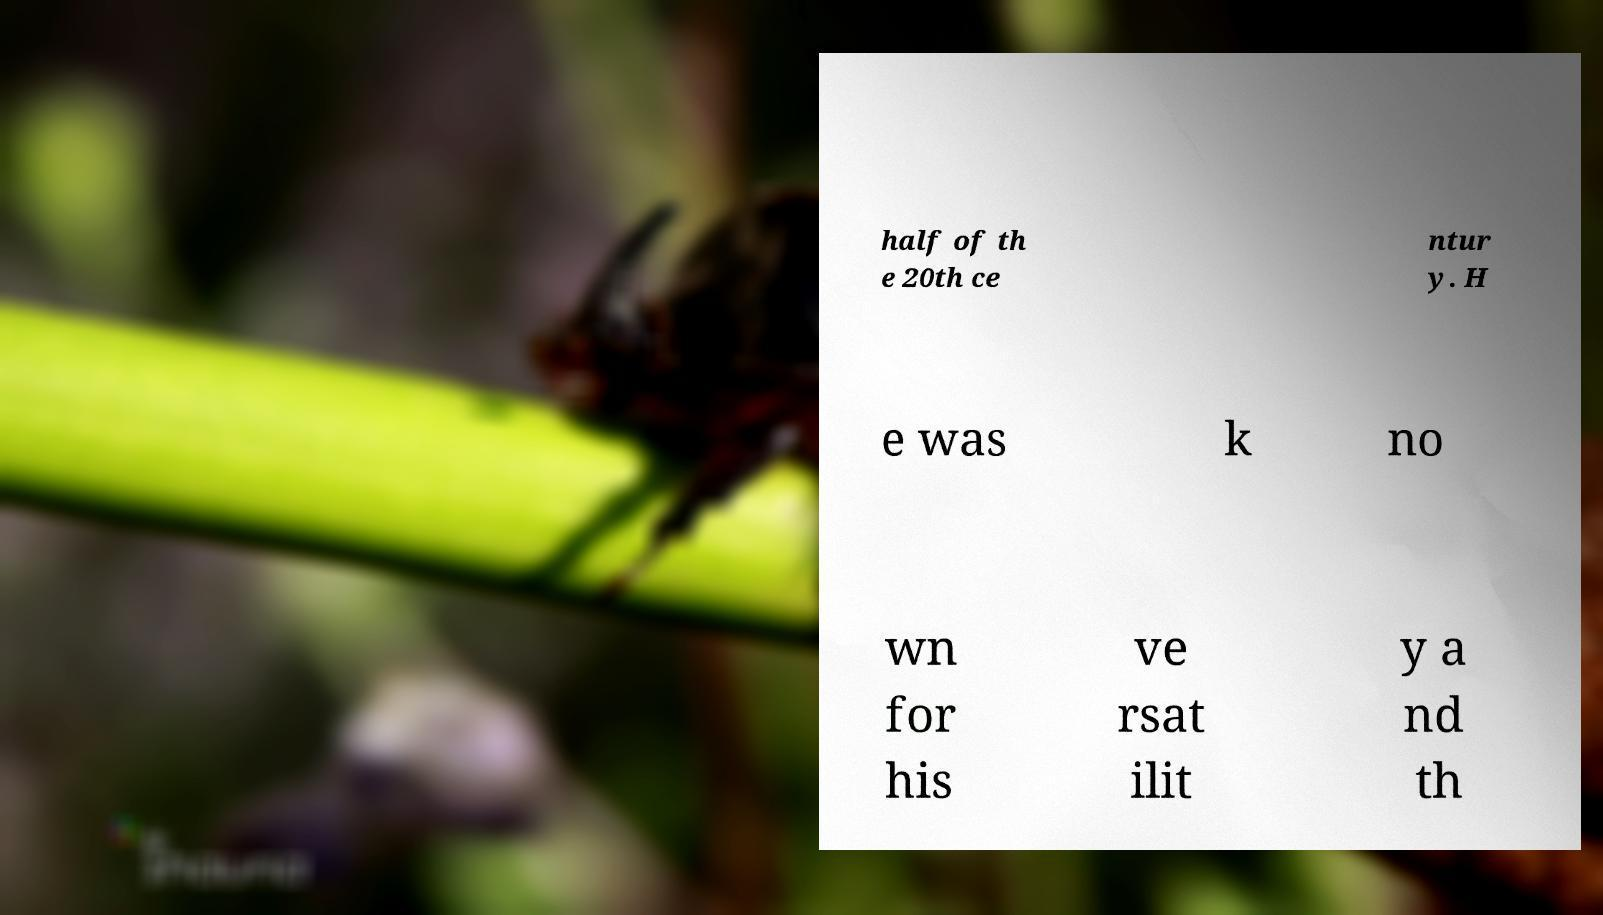Please read and relay the text visible in this image. What does it say? half of th e 20th ce ntur y. H e was k no wn for his ve rsat ilit y a nd th 